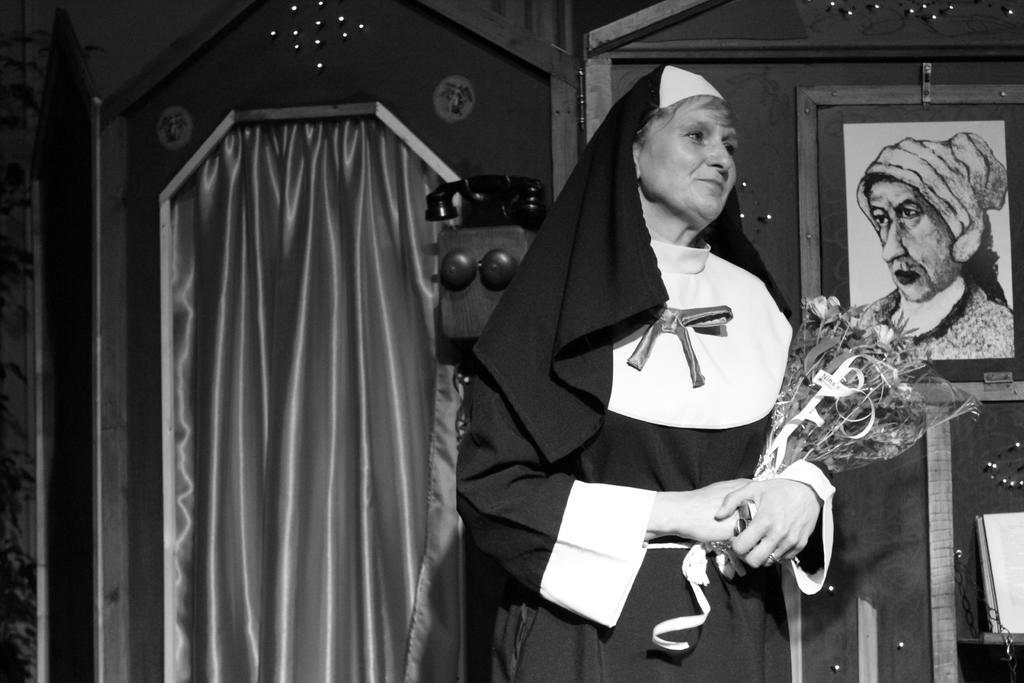Can you describe this image briefly? In this image in the front there is a woman standing and holding a bouquet in her hand. In the background there is a curtain which is black in colour and there is a frame on the wall and there is a telephone and there is an object which is white in colour kept on the shelf. 